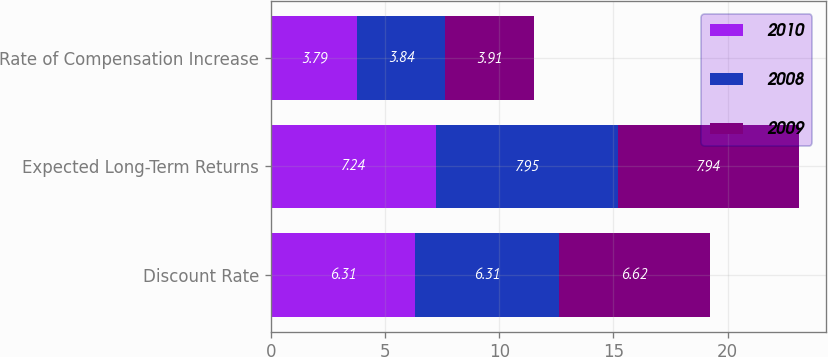Convert chart. <chart><loc_0><loc_0><loc_500><loc_500><stacked_bar_chart><ecel><fcel>Discount Rate<fcel>Expected Long-Term Returns<fcel>Rate of Compensation Increase<nl><fcel>2010<fcel>6.31<fcel>7.24<fcel>3.79<nl><fcel>2008<fcel>6.31<fcel>7.95<fcel>3.84<nl><fcel>2009<fcel>6.62<fcel>7.94<fcel>3.91<nl></chart> 